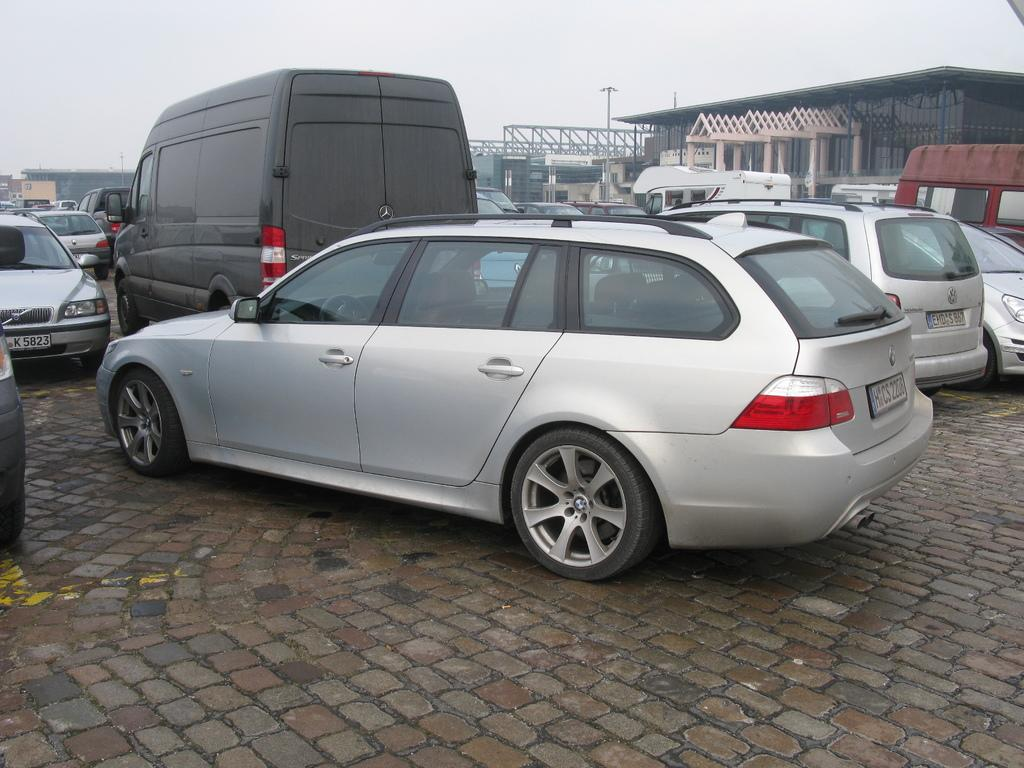What type of vehicles can be seen in the image? There are cars in the image. What unique structure is located on the right side of the image? There is a glass house on the right side of the image. What is visible at the top of the image? The sky is visible at the top of the image. What type of scarf is draped over the chain in the image? There is no scarf or chain present in the image. 